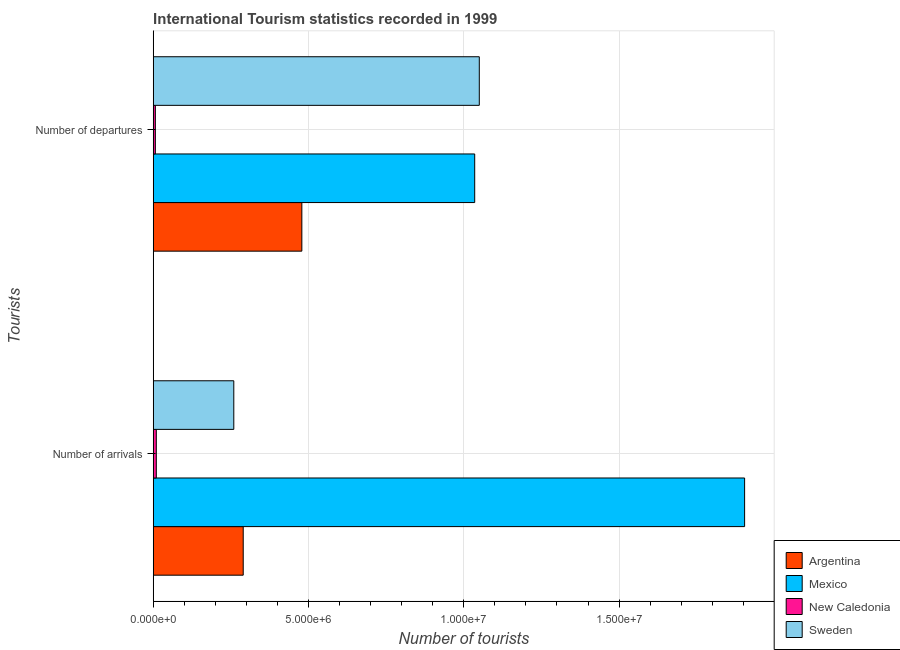How many groups of bars are there?
Provide a short and direct response. 2. Are the number of bars on each tick of the Y-axis equal?
Keep it short and to the point. Yes. How many bars are there on the 2nd tick from the bottom?
Your answer should be compact. 4. What is the label of the 1st group of bars from the top?
Your answer should be very brief. Number of departures. What is the number of tourist arrivals in Sweden?
Your response must be concise. 2.60e+06. Across all countries, what is the maximum number of tourist departures?
Your response must be concise. 1.05e+07. Across all countries, what is the minimum number of tourist departures?
Offer a terse response. 6.90e+04. In which country was the number of tourist arrivals minimum?
Ensure brevity in your answer.  New Caledonia. What is the total number of tourist arrivals in the graph?
Your answer should be compact. 2.46e+07. What is the difference between the number of tourist departures in New Caledonia and that in Mexico?
Ensure brevity in your answer.  -1.03e+07. What is the difference between the number of tourist arrivals in Sweden and the number of tourist departures in Mexico?
Your answer should be very brief. -7.76e+06. What is the average number of tourist arrivals per country?
Provide a short and direct response. 6.16e+06. What is the difference between the number of tourist departures and number of tourist arrivals in Mexico?
Your response must be concise. -8.69e+06. What is the ratio of the number of tourist arrivals in Argentina to that in Sweden?
Ensure brevity in your answer.  1.12. Is the number of tourist arrivals in New Caledonia less than that in Mexico?
Your answer should be compact. Yes. In how many countries, is the number of tourist departures greater than the average number of tourist departures taken over all countries?
Your response must be concise. 2. What does the 4th bar from the bottom in Number of arrivals represents?
Offer a terse response. Sweden. How many bars are there?
Provide a short and direct response. 8. Are the values on the major ticks of X-axis written in scientific E-notation?
Your answer should be very brief. Yes. Where does the legend appear in the graph?
Make the answer very short. Bottom right. How are the legend labels stacked?
Provide a succinct answer. Vertical. What is the title of the graph?
Offer a terse response. International Tourism statistics recorded in 1999. Does "Chad" appear as one of the legend labels in the graph?
Your response must be concise. No. What is the label or title of the X-axis?
Ensure brevity in your answer.  Number of tourists. What is the label or title of the Y-axis?
Keep it short and to the point. Tourists. What is the Number of tourists of Argentina in Number of arrivals?
Offer a terse response. 2.90e+06. What is the Number of tourists of Mexico in Number of arrivals?
Keep it short and to the point. 1.90e+07. What is the Number of tourists in New Caledonia in Number of arrivals?
Make the answer very short. 1.00e+05. What is the Number of tourists in Sweden in Number of arrivals?
Ensure brevity in your answer.  2.60e+06. What is the Number of tourists in Argentina in Number of departures?
Your answer should be very brief. 4.79e+06. What is the Number of tourists in Mexico in Number of departures?
Ensure brevity in your answer.  1.04e+07. What is the Number of tourists of New Caledonia in Number of departures?
Your response must be concise. 6.90e+04. What is the Number of tourists in Sweden in Number of departures?
Your response must be concise. 1.05e+07. Across all Tourists, what is the maximum Number of tourists of Argentina?
Give a very brief answer. 4.79e+06. Across all Tourists, what is the maximum Number of tourists of Mexico?
Your answer should be very brief. 1.90e+07. Across all Tourists, what is the maximum Number of tourists of New Caledonia?
Provide a short and direct response. 1.00e+05. Across all Tourists, what is the maximum Number of tourists in Sweden?
Your response must be concise. 1.05e+07. Across all Tourists, what is the minimum Number of tourists in Argentina?
Make the answer very short. 2.90e+06. Across all Tourists, what is the minimum Number of tourists of Mexico?
Your answer should be compact. 1.04e+07. Across all Tourists, what is the minimum Number of tourists in New Caledonia?
Your response must be concise. 6.90e+04. Across all Tourists, what is the minimum Number of tourists in Sweden?
Keep it short and to the point. 2.60e+06. What is the total Number of tourists of Argentina in the graph?
Keep it short and to the point. 7.68e+06. What is the total Number of tourists of Mexico in the graph?
Make the answer very short. 2.94e+07. What is the total Number of tourists in New Caledonia in the graph?
Provide a short and direct response. 1.69e+05. What is the total Number of tourists in Sweden in the graph?
Provide a short and direct response. 1.31e+07. What is the difference between the Number of tourists in Argentina in Number of arrivals and that in Number of departures?
Provide a succinct answer. -1.89e+06. What is the difference between the Number of tourists in Mexico in Number of arrivals and that in Number of departures?
Keep it short and to the point. 8.69e+06. What is the difference between the Number of tourists in New Caledonia in Number of arrivals and that in Number of departures?
Make the answer very short. 3.10e+04. What is the difference between the Number of tourists in Sweden in Number of arrivals and that in Number of departures?
Your response must be concise. -7.90e+06. What is the difference between the Number of tourists in Argentina in Number of arrivals and the Number of tourists in Mexico in Number of departures?
Provide a short and direct response. -7.45e+06. What is the difference between the Number of tourists in Argentina in Number of arrivals and the Number of tourists in New Caledonia in Number of departures?
Offer a terse response. 2.83e+06. What is the difference between the Number of tourists of Argentina in Number of arrivals and the Number of tourists of Sweden in Number of departures?
Give a very brief answer. -7.60e+06. What is the difference between the Number of tourists in Mexico in Number of arrivals and the Number of tourists in New Caledonia in Number of departures?
Provide a succinct answer. 1.90e+07. What is the difference between the Number of tourists in Mexico in Number of arrivals and the Number of tourists in Sweden in Number of departures?
Your response must be concise. 8.54e+06. What is the difference between the Number of tourists in New Caledonia in Number of arrivals and the Number of tourists in Sweden in Number of departures?
Provide a short and direct response. -1.04e+07. What is the average Number of tourists in Argentina per Tourists?
Ensure brevity in your answer.  3.84e+06. What is the average Number of tourists of Mexico per Tourists?
Your answer should be very brief. 1.47e+07. What is the average Number of tourists of New Caledonia per Tourists?
Your response must be concise. 8.45e+04. What is the average Number of tourists of Sweden per Tourists?
Give a very brief answer. 6.55e+06. What is the difference between the Number of tourists in Argentina and Number of tourists in Mexico in Number of arrivals?
Ensure brevity in your answer.  -1.61e+07. What is the difference between the Number of tourists in Argentina and Number of tourists in New Caledonia in Number of arrivals?
Your answer should be very brief. 2.80e+06. What is the difference between the Number of tourists in Argentina and Number of tourists in Sweden in Number of arrivals?
Your answer should be compact. 3.03e+05. What is the difference between the Number of tourists of Mexico and Number of tourists of New Caledonia in Number of arrivals?
Give a very brief answer. 1.89e+07. What is the difference between the Number of tourists in Mexico and Number of tourists in Sweden in Number of arrivals?
Provide a succinct answer. 1.64e+07. What is the difference between the Number of tourists in New Caledonia and Number of tourists in Sweden in Number of arrivals?
Your answer should be compact. -2.50e+06. What is the difference between the Number of tourists of Argentina and Number of tourists of Mexico in Number of departures?
Provide a short and direct response. -5.57e+06. What is the difference between the Number of tourists of Argentina and Number of tourists of New Caledonia in Number of departures?
Give a very brief answer. 4.72e+06. What is the difference between the Number of tourists of Argentina and Number of tourists of Sweden in Number of departures?
Offer a terse response. -5.71e+06. What is the difference between the Number of tourists of Mexico and Number of tourists of New Caledonia in Number of departures?
Offer a terse response. 1.03e+07. What is the difference between the Number of tourists of Mexico and Number of tourists of Sweden in Number of departures?
Your response must be concise. -1.48e+05. What is the difference between the Number of tourists in New Caledonia and Number of tourists in Sweden in Number of departures?
Ensure brevity in your answer.  -1.04e+07. What is the ratio of the Number of tourists in Argentina in Number of arrivals to that in Number of departures?
Give a very brief answer. 0.61. What is the ratio of the Number of tourists in Mexico in Number of arrivals to that in Number of departures?
Your answer should be compact. 1.84. What is the ratio of the Number of tourists of New Caledonia in Number of arrivals to that in Number of departures?
Offer a very short reply. 1.45. What is the ratio of the Number of tourists in Sweden in Number of arrivals to that in Number of departures?
Make the answer very short. 0.25. What is the difference between the highest and the second highest Number of tourists in Argentina?
Your answer should be very brief. 1.89e+06. What is the difference between the highest and the second highest Number of tourists of Mexico?
Offer a terse response. 8.69e+06. What is the difference between the highest and the second highest Number of tourists of New Caledonia?
Your answer should be compact. 3.10e+04. What is the difference between the highest and the second highest Number of tourists in Sweden?
Ensure brevity in your answer.  7.90e+06. What is the difference between the highest and the lowest Number of tourists in Argentina?
Offer a terse response. 1.89e+06. What is the difference between the highest and the lowest Number of tourists of Mexico?
Give a very brief answer. 8.69e+06. What is the difference between the highest and the lowest Number of tourists in New Caledonia?
Make the answer very short. 3.10e+04. What is the difference between the highest and the lowest Number of tourists of Sweden?
Provide a short and direct response. 7.90e+06. 